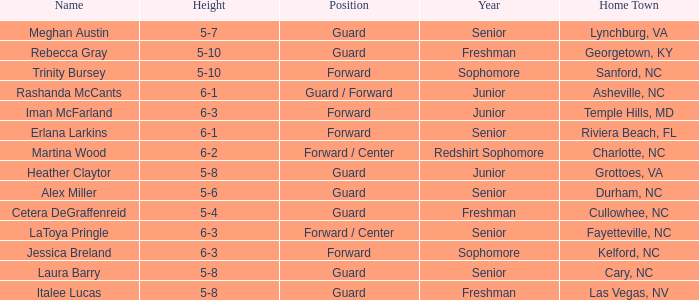What is the height of the player from Las Vegas, NV? 5-8. 